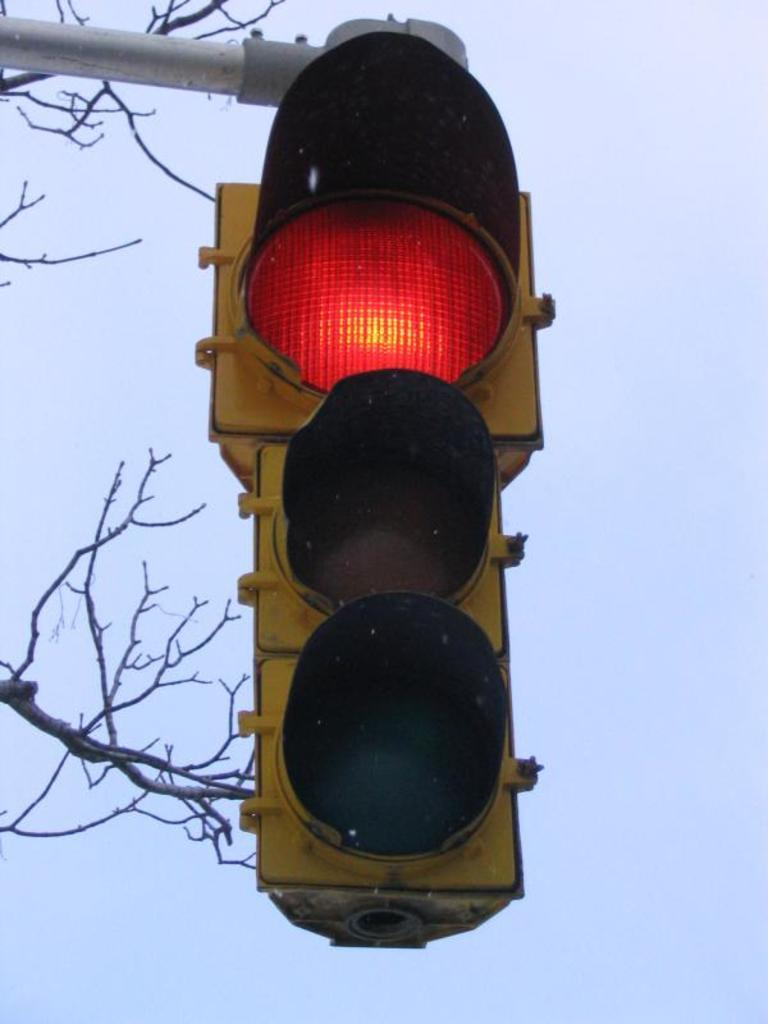What is the main object in the image? There is a traffic signal in the image. How is the traffic signal attached to its support? The traffic signal is attached to a pole. What type of vegetation can be seen in the image? There are branches and stems in the image. What can be seen in the distance in the image? The sky is visible in the background of the image. What type of event is taking place in the image? There is no event taking place in the image; it simply shows a traffic signal attached to a pole with branches and stems in the foreground and the sky in the background. 